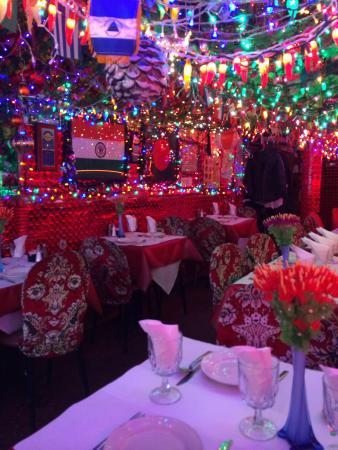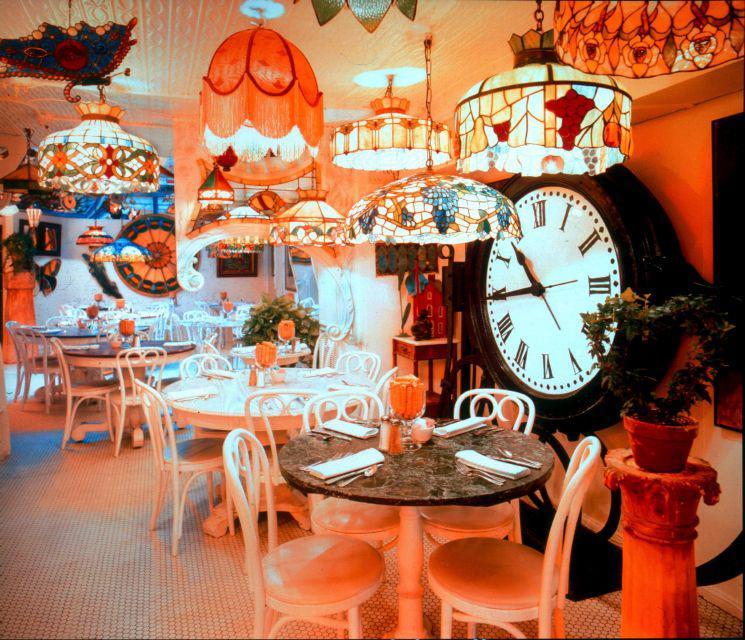The first image is the image on the left, the second image is the image on the right. Considering the images on both sides, is "There are lights hanging from the ceiling in both images." valid? Answer yes or no. Yes. The first image is the image on the left, the second image is the image on the right. Analyze the images presented: Is the assertion "There are two empty cafes with no more than one person in the whole image." valid? Answer yes or no. Yes. 